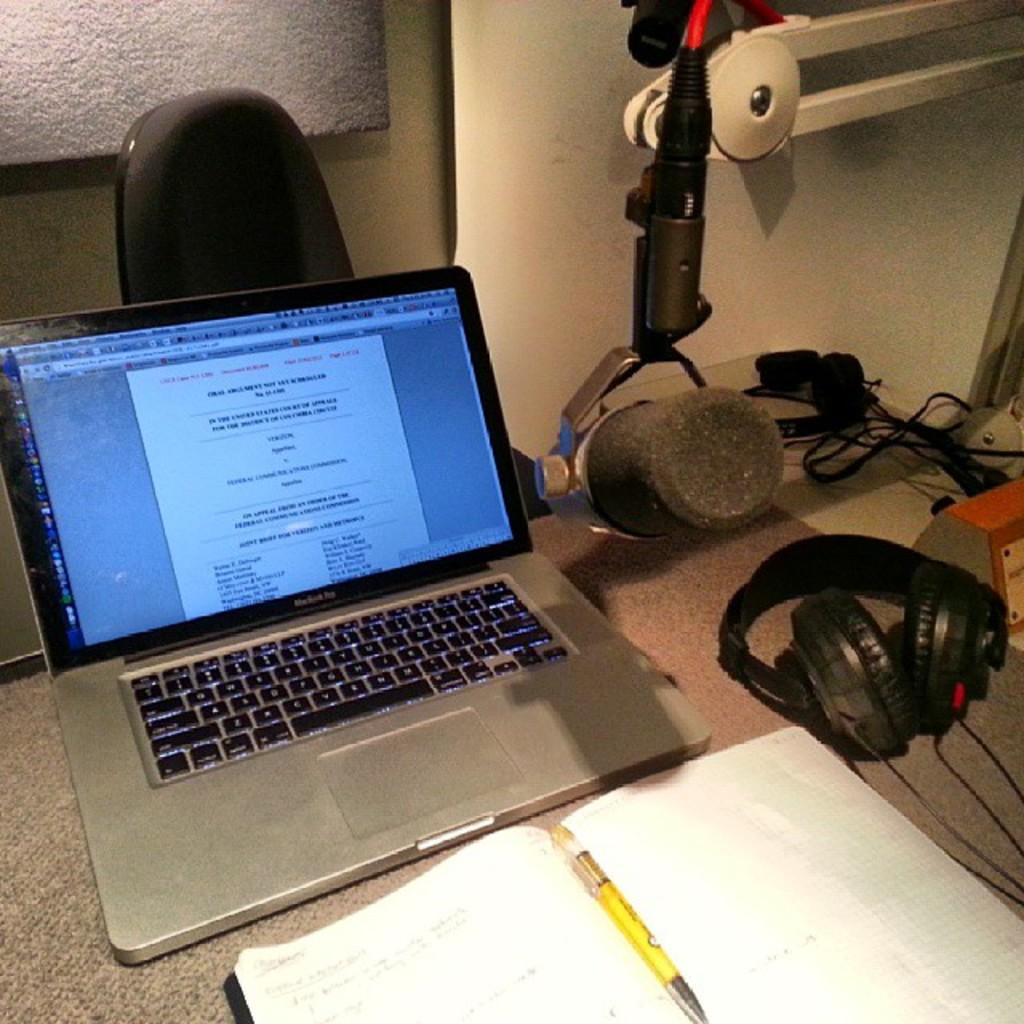What electronic device is present in the image? There is a laptop in the image. What type of reading material is visible in the image? There is a book in the image. What writing instrument is present in the image? There is a pen in the image. What device is used for audio communication in the image? There is a headset in the image. Where are the objects placed in the image? The objects are on a platform. What type of furniture is in the image? There is a chair in the image. What type of wiring is visible in the image? Cables are visible in the image. What type of structure is visible in the background of the image? There is a wall in the image. What type of leg is visible in the image? There is no leg visible in the image; the focus is on the objects and furniture. 